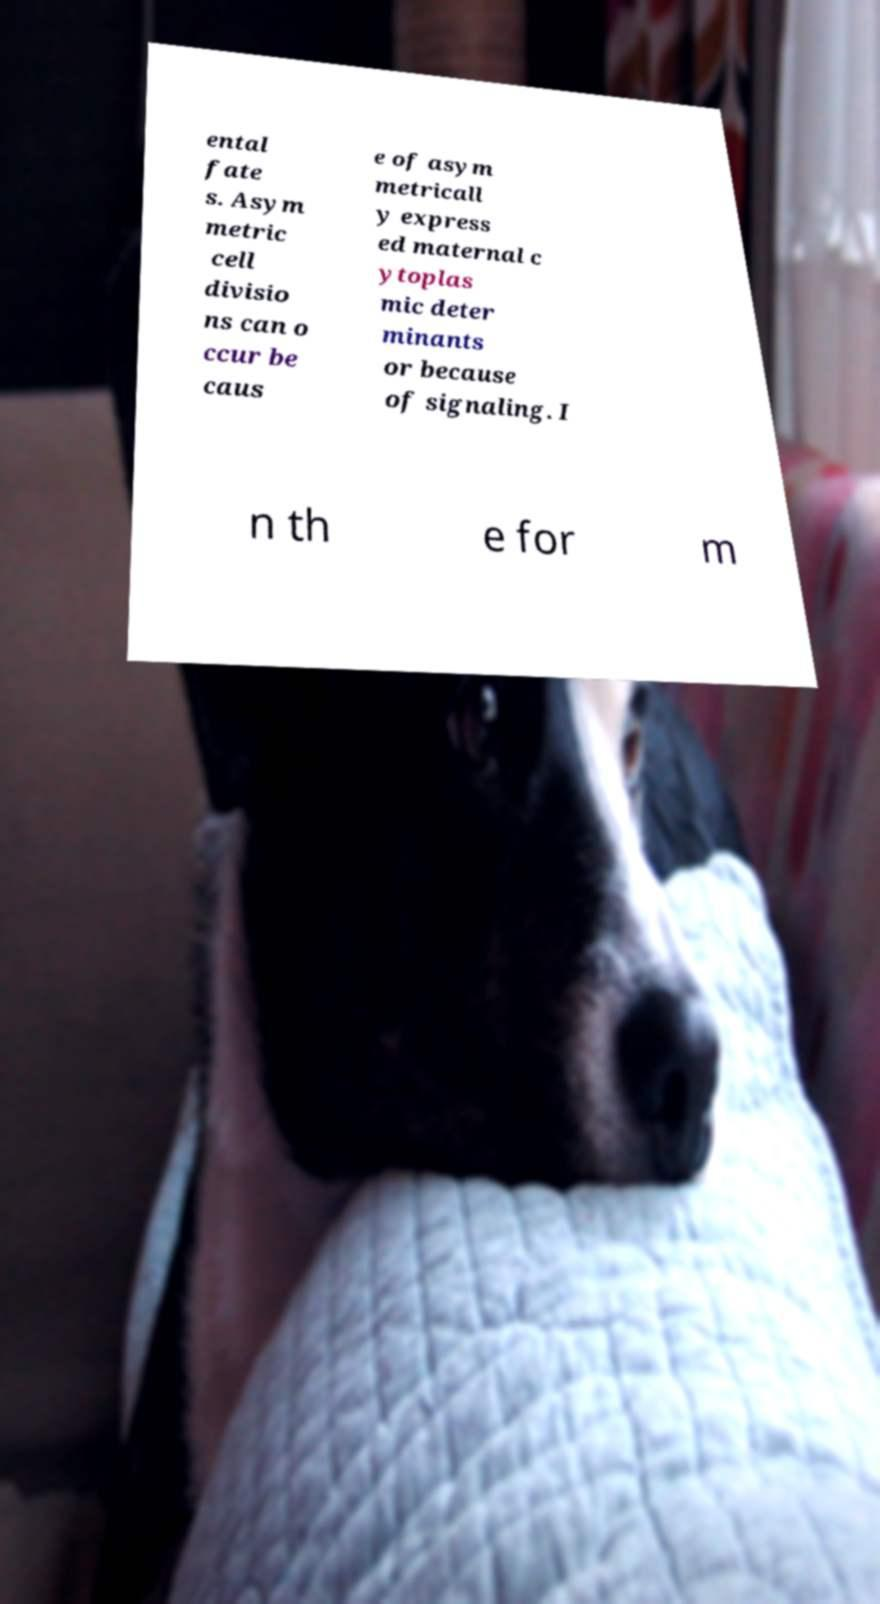Please read and relay the text visible in this image. What does it say? ental fate s. Asym metric cell divisio ns can o ccur be caus e of asym metricall y express ed maternal c ytoplas mic deter minants or because of signaling. I n th e for m 